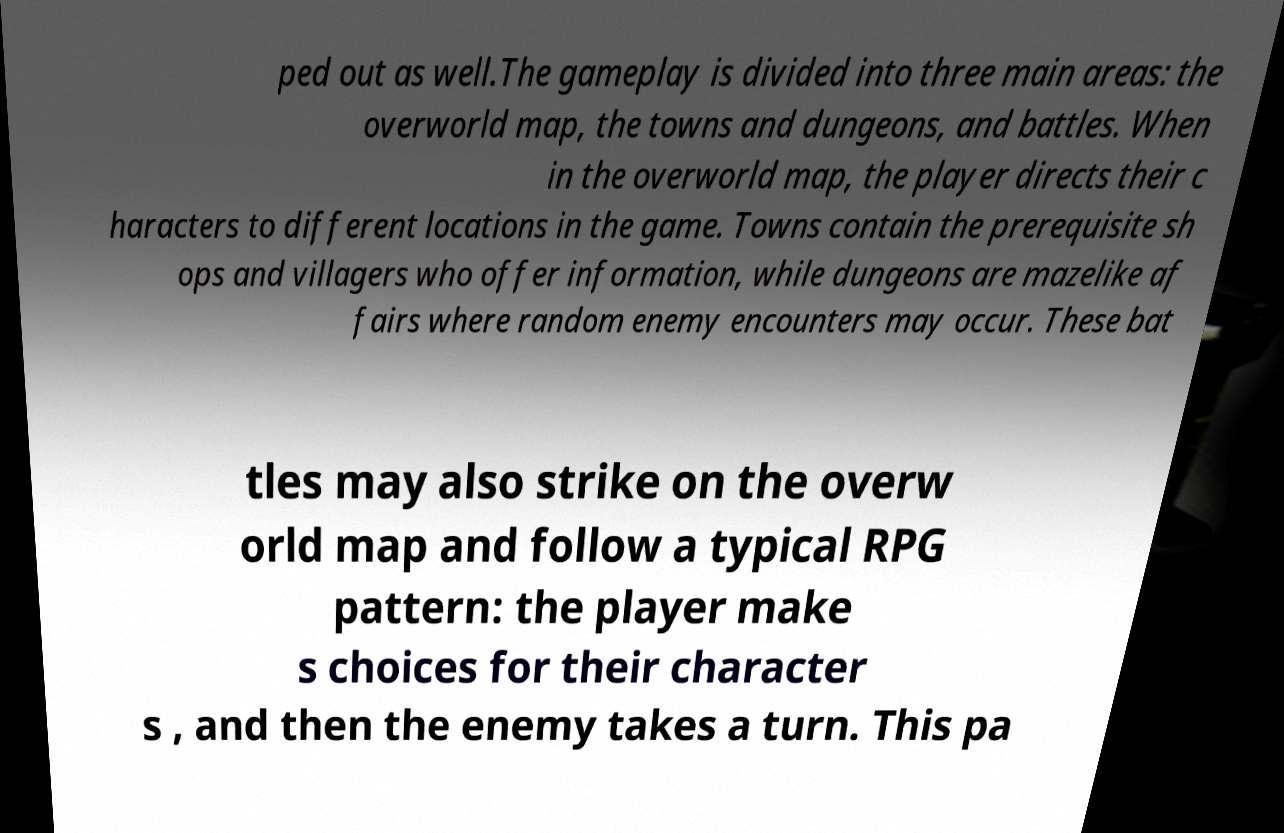Please read and relay the text visible in this image. What does it say? ped out as well.The gameplay is divided into three main areas: the overworld map, the towns and dungeons, and battles. When in the overworld map, the player directs their c haracters to different locations in the game. Towns contain the prerequisite sh ops and villagers who offer information, while dungeons are mazelike af fairs where random enemy encounters may occur. These bat tles may also strike on the overw orld map and follow a typical RPG pattern: the player make s choices for their character s , and then the enemy takes a turn. This pa 